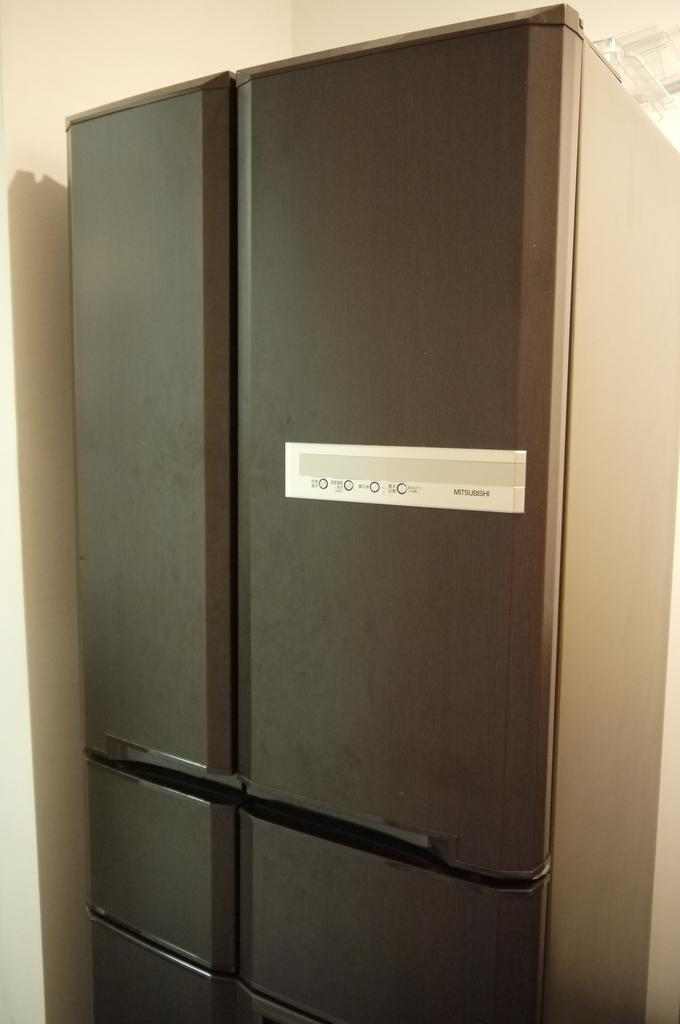<image>
Relay a brief, clear account of the picture shown. A large metal colored fridge from the company Mitsubishi 